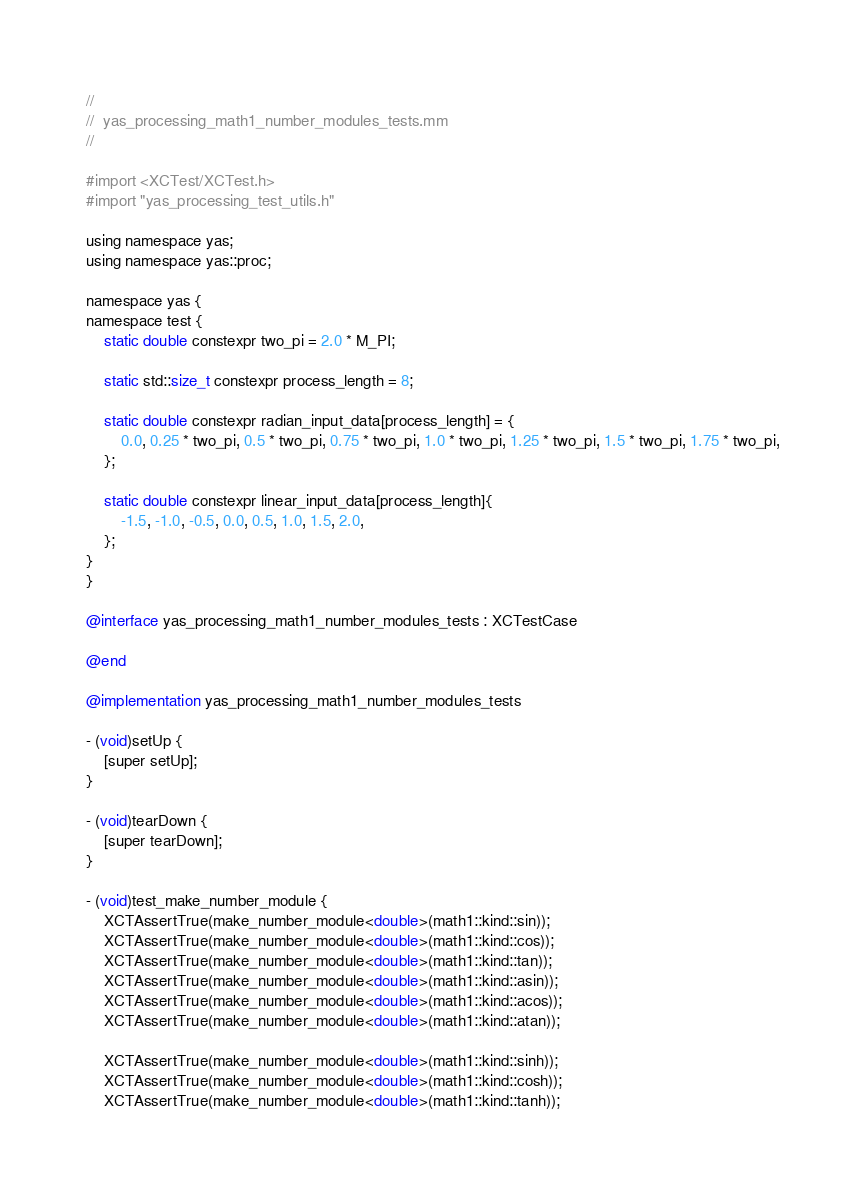Convert code to text. <code><loc_0><loc_0><loc_500><loc_500><_ObjectiveC_>//
//  yas_processing_math1_number_modules_tests.mm
//

#import <XCTest/XCTest.h>
#import "yas_processing_test_utils.h"

using namespace yas;
using namespace yas::proc;

namespace yas {
namespace test {
    static double constexpr two_pi = 2.0 * M_PI;

    static std::size_t constexpr process_length = 8;

    static double constexpr radian_input_data[process_length] = {
        0.0, 0.25 * two_pi, 0.5 * two_pi, 0.75 * two_pi, 1.0 * two_pi, 1.25 * two_pi, 1.5 * two_pi, 1.75 * two_pi,
    };

    static double constexpr linear_input_data[process_length]{
        -1.5, -1.0, -0.5, 0.0, 0.5, 1.0, 1.5, 2.0,
    };
}
}

@interface yas_processing_math1_number_modules_tests : XCTestCase

@end

@implementation yas_processing_math1_number_modules_tests

- (void)setUp {
    [super setUp];
}

- (void)tearDown {
    [super tearDown];
}

- (void)test_make_number_module {
    XCTAssertTrue(make_number_module<double>(math1::kind::sin));
    XCTAssertTrue(make_number_module<double>(math1::kind::cos));
    XCTAssertTrue(make_number_module<double>(math1::kind::tan));
    XCTAssertTrue(make_number_module<double>(math1::kind::asin));
    XCTAssertTrue(make_number_module<double>(math1::kind::acos));
    XCTAssertTrue(make_number_module<double>(math1::kind::atan));

    XCTAssertTrue(make_number_module<double>(math1::kind::sinh));
    XCTAssertTrue(make_number_module<double>(math1::kind::cosh));
    XCTAssertTrue(make_number_module<double>(math1::kind::tanh));</code> 